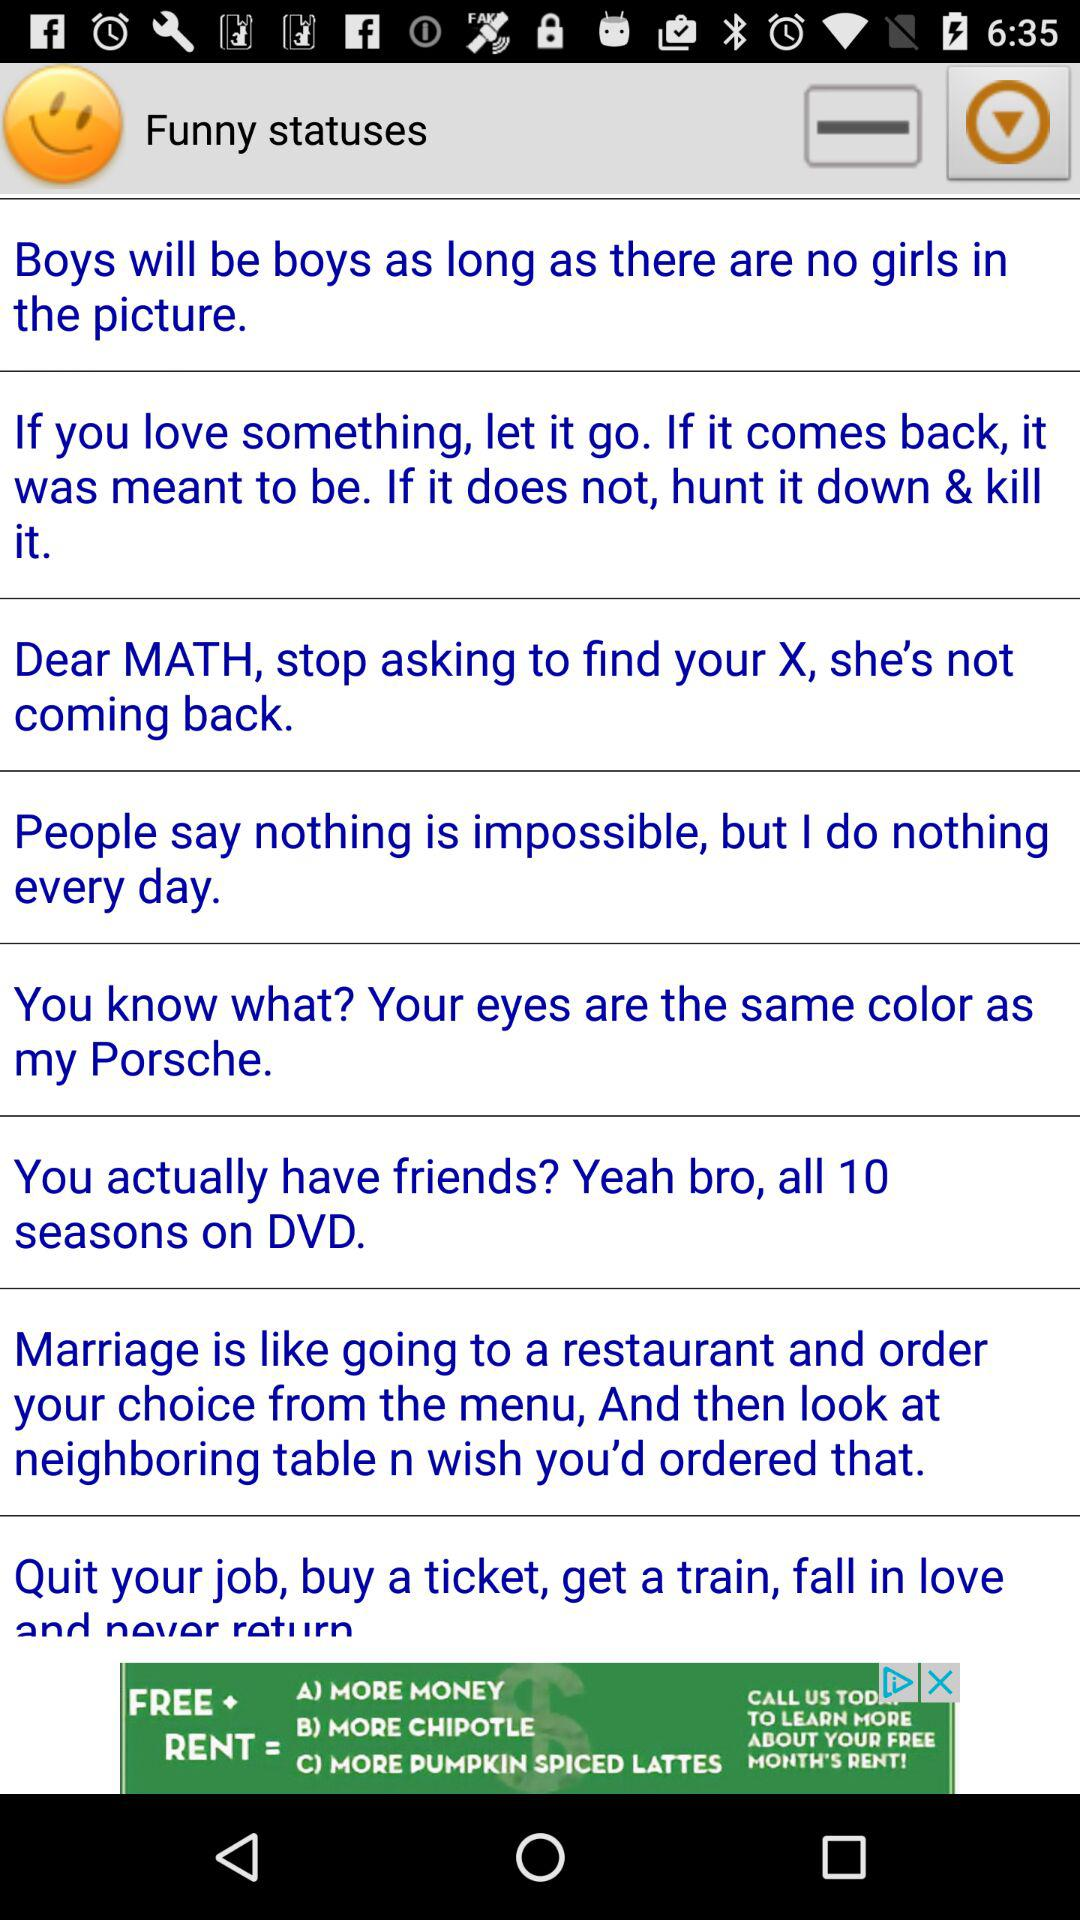What is the list of "Funny statuses"? The lists are: "Boys will be boys as long as there are no girls in the picture", "If you love something, let it go. If it comes back, it was meant to be. If it does not, hunt it down & kill it.", "Dear MATH, stop asking to find your X, she's not coming back.", "People say nothing is impossible, but I do nothing every day.", "You know what? Your eyes are the same color as my Porsche.", "You actually have friends? Yeah bro, all 10 seasons on DVD.", "Marriage is like going to a restaurant and order your choice from the menu, And then look at neighboring table n wish you'd ordered that.", "Quit your job, buy a ticket, get a train, fall in love and never return.". 